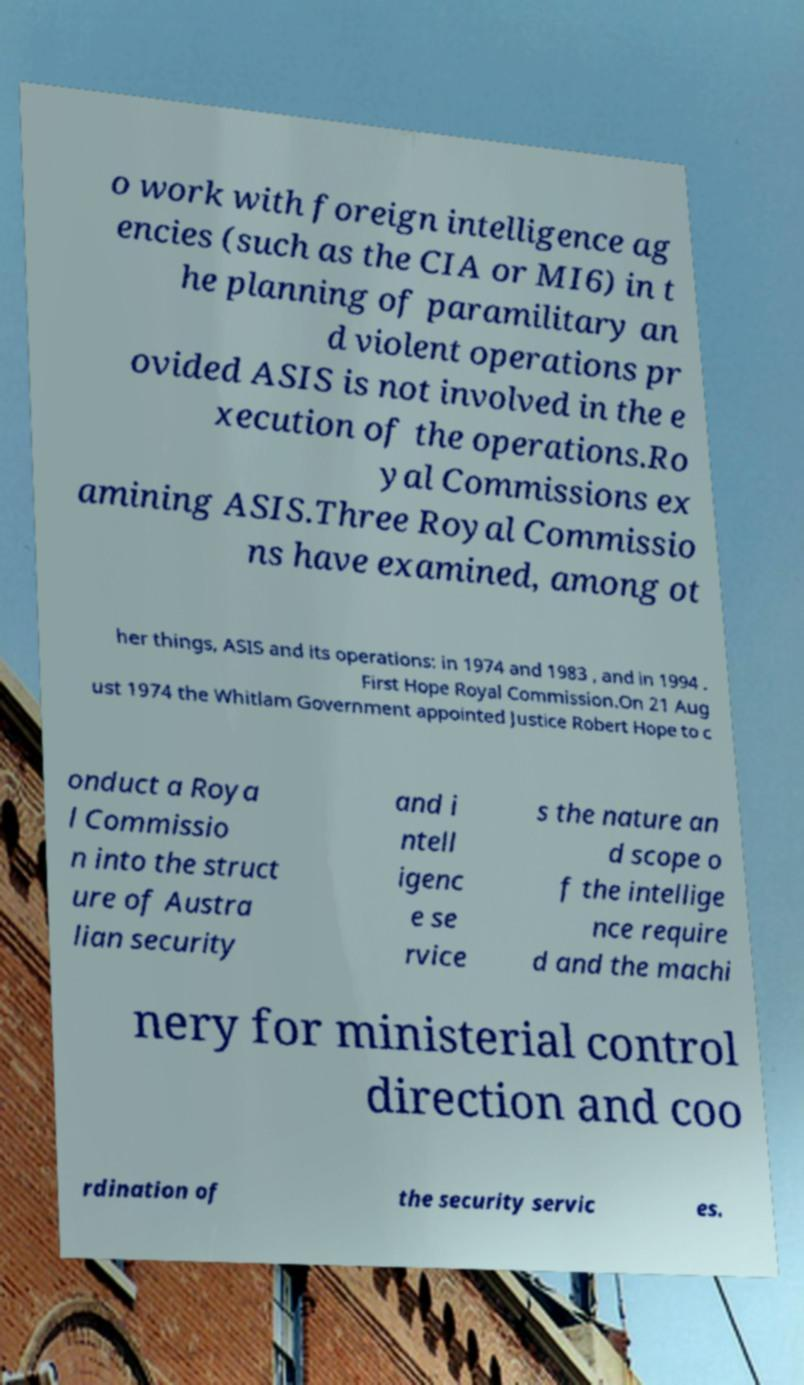Could you assist in decoding the text presented in this image and type it out clearly? o work with foreign intelligence ag encies (such as the CIA or MI6) in t he planning of paramilitary an d violent operations pr ovided ASIS is not involved in the e xecution of the operations.Ro yal Commissions ex amining ASIS.Three Royal Commissio ns have examined, among ot her things, ASIS and its operations: in 1974 and 1983 , and in 1994 . First Hope Royal Commission.On 21 Aug ust 1974 the Whitlam Government appointed Justice Robert Hope to c onduct a Roya l Commissio n into the struct ure of Austra lian security and i ntell igenc e se rvice s the nature an d scope o f the intellige nce require d and the machi nery for ministerial control direction and coo rdination of the security servic es. 